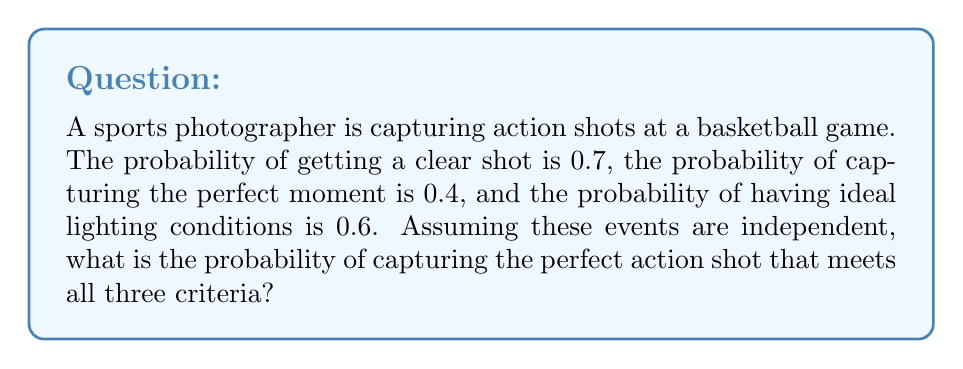Provide a solution to this math problem. To solve this problem, we need to use the multiplication rule for independent events. Since we're looking for the probability of all three conditions being met simultaneously, and they are independent, we multiply their individual probabilities:

1. Let $A$ be the event of getting a clear shot, $P(A) = 0.7$
2. Let $B$ be the event of capturing the perfect moment, $P(B) = 0.4$
3. Let $C$ be the event of having ideal lighting conditions, $P(C) = 0.6$

The probability of all three events occurring together is:

$$P(A \cap B \cap C) = P(A) \times P(B) \times P(C)$$

Substituting the given probabilities:

$$P(A \cap B \cap C) = 0.7 \times 0.4 \times 0.6$$

Calculating:

$$P(A \cap B \cap C) = 0.168$$

Therefore, the probability of capturing the perfect action shot that meets all three criteria is 0.168 or 16.8%.
Answer: 0.168 